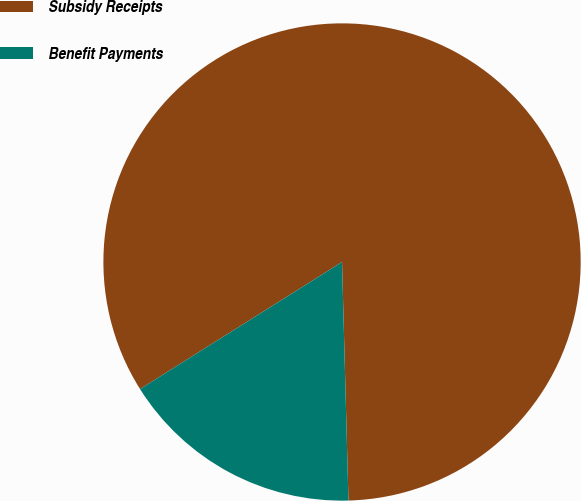Convert chart. <chart><loc_0><loc_0><loc_500><loc_500><pie_chart><fcel>Subsidy Receipts<fcel>Benefit Payments<nl><fcel>83.51%<fcel>16.49%<nl></chart> 